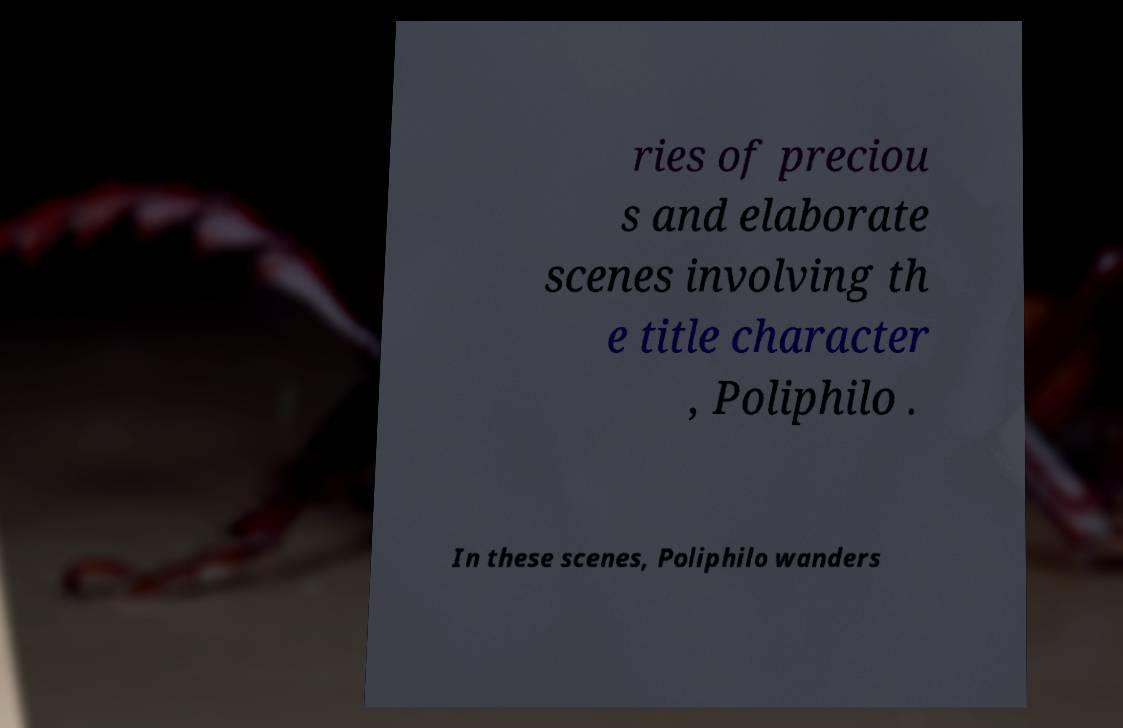Can you accurately transcribe the text from the provided image for me? ries of preciou s and elaborate scenes involving th e title character , Poliphilo . In these scenes, Poliphilo wanders 